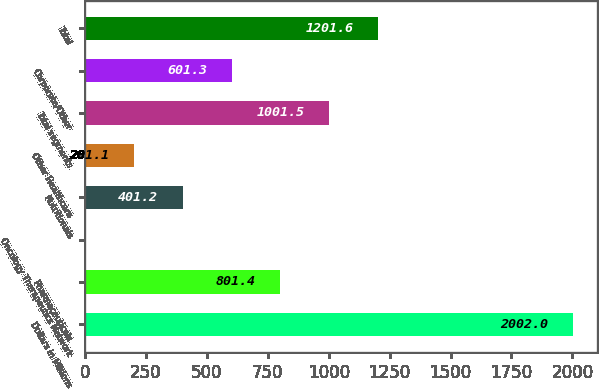Convert chart to OTSL. <chart><loc_0><loc_0><loc_500><loc_500><bar_chart><fcel>Dollars in Millions<fcel>Pharmaceuticals<fcel>Oncology Therapeutics Network<fcel>Nutritionals<fcel>Other Healthcare<fcel>Total segments<fcel>Corporate/Other<fcel>Total<nl><fcel>2002<fcel>801.4<fcel>1<fcel>401.2<fcel>201.1<fcel>1001.5<fcel>601.3<fcel>1201.6<nl></chart> 